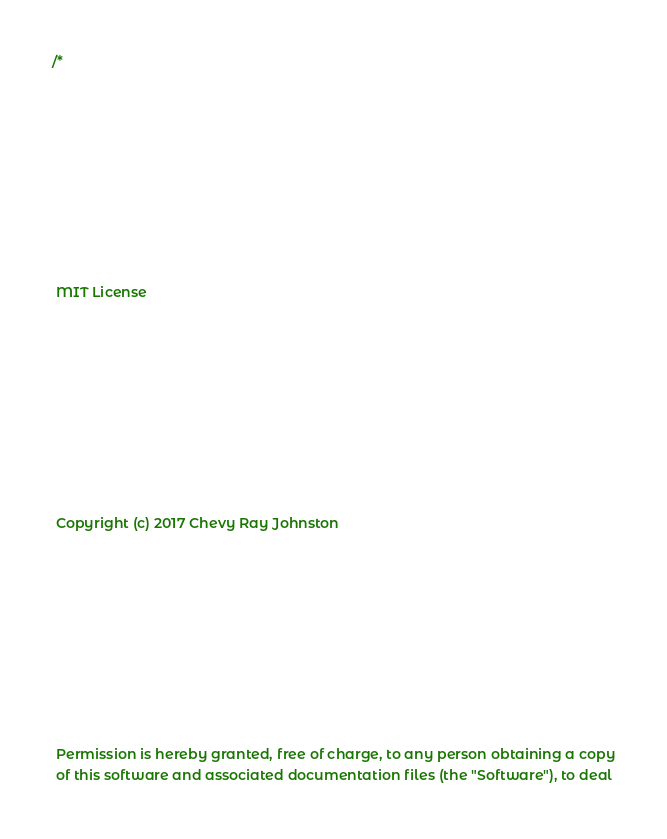Convert code to text. <code><loc_0><loc_0><loc_500><loc_500><_C++_>/*
 
 MIT License
 
 Copyright (c) 2017 Chevy Ray Johnston
 
 Permission is hereby granted, free of charge, to any person obtaining a copy
 of this software and associated documentation files (the "Software"), to deal</code> 